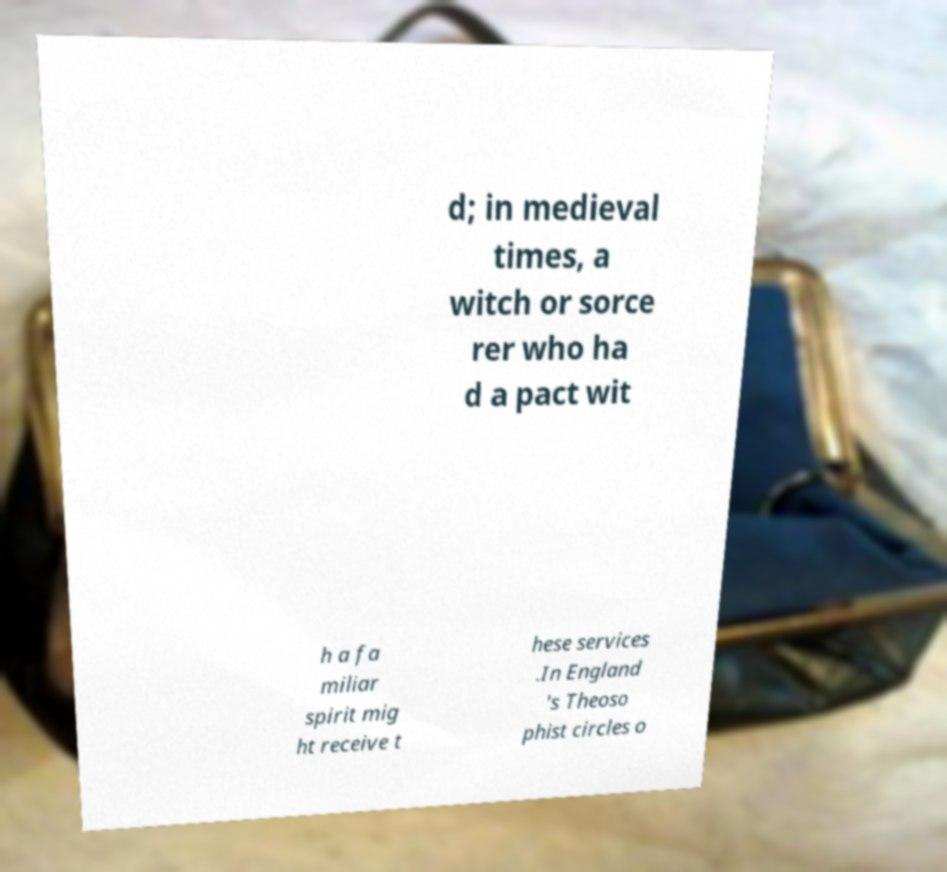Could you extract and type out the text from this image? d; in medieval times, a witch or sorce rer who ha d a pact wit h a fa miliar spirit mig ht receive t hese services .In England 's Theoso phist circles o 